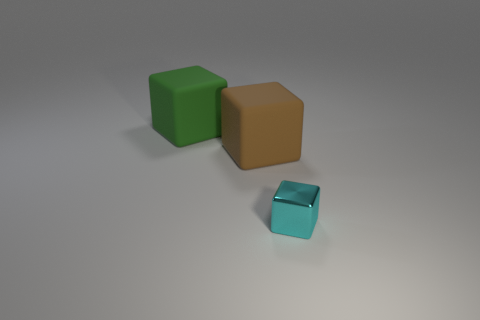Add 1 large brown rubber cubes. How many objects exist? 4 Subtract all rubber blocks. How many blocks are left? 1 Subtract all blue cubes. Subtract all brown spheres. How many cubes are left? 3 Add 2 brown matte cubes. How many brown matte cubes are left? 3 Add 1 large green matte things. How many large green matte things exist? 2 Subtract 0 blue cylinders. How many objects are left? 3 Subtract all big rubber blocks. Subtract all green matte blocks. How many objects are left? 0 